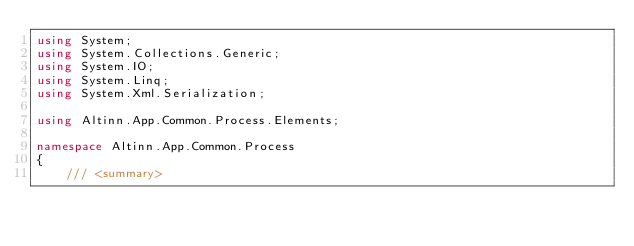Convert code to text. <code><loc_0><loc_0><loc_500><loc_500><_C#_>using System;
using System.Collections.Generic;
using System.IO;
using System.Linq;
using System.Xml.Serialization;

using Altinn.App.Common.Process.Elements;

namespace Altinn.App.Common.Process
{
    /// <summary></code> 